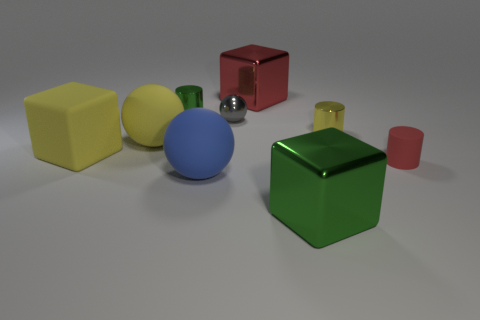Add 1 large gray cubes. How many objects exist? 10 Subtract all green metallic cylinders. How many cylinders are left? 2 Subtract 1 red cubes. How many objects are left? 8 Subtract all cylinders. How many objects are left? 6 Subtract 1 cylinders. How many cylinders are left? 2 Subtract all red cylinders. Subtract all blue balls. How many cylinders are left? 2 Subtract all gray cubes. How many green cylinders are left? 1 Subtract all large metal things. Subtract all red rubber cylinders. How many objects are left? 6 Add 8 yellow matte balls. How many yellow matte balls are left? 9 Add 7 green blocks. How many green blocks exist? 8 